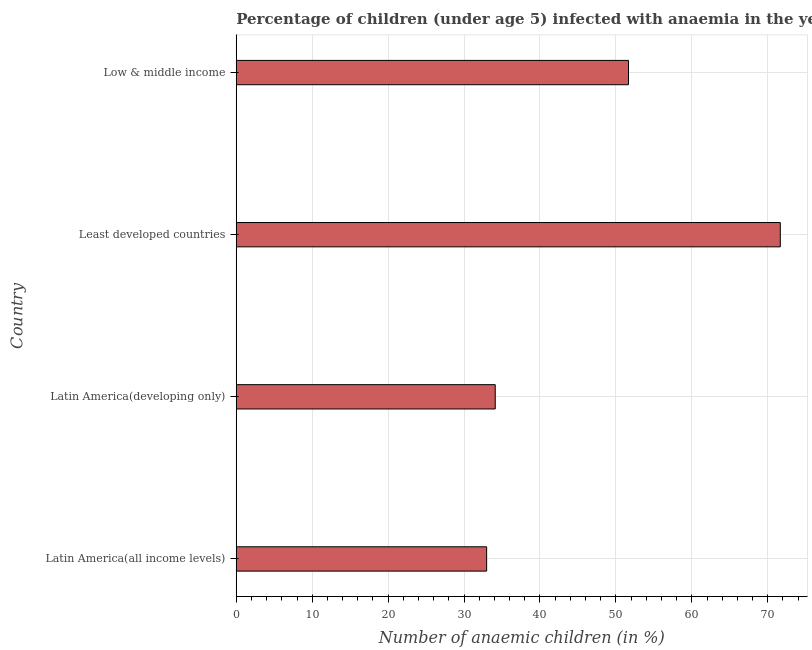Does the graph contain grids?
Provide a succinct answer. Yes. What is the title of the graph?
Give a very brief answer. Percentage of children (under age 5) infected with anaemia in the year 1996. What is the label or title of the X-axis?
Make the answer very short. Number of anaemic children (in %). What is the number of anaemic children in Latin America(all income levels)?
Provide a short and direct response. 32.98. Across all countries, what is the maximum number of anaemic children?
Your response must be concise. 71.65. Across all countries, what is the minimum number of anaemic children?
Provide a succinct answer. 32.98. In which country was the number of anaemic children maximum?
Offer a very short reply. Least developed countries. In which country was the number of anaemic children minimum?
Make the answer very short. Latin America(all income levels). What is the sum of the number of anaemic children?
Provide a short and direct response. 190.4. What is the difference between the number of anaemic children in Least developed countries and Low & middle income?
Offer a very short reply. 19.99. What is the average number of anaemic children per country?
Provide a short and direct response. 47.6. What is the median number of anaemic children?
Provide a short and direct response. 42.88. What is the ratio of the number of anaemic children in Latin America(all income levels) to that in Low & middle income?
Your answer should be very brief. 0.64. Is the difference between the number of anaemic children in Latin America(all income levels) and Least developed countries greater than the difference between any two countries?
Ensure brevity in your answer.  Yes. What is the difference between the highest and the second highest number of anaemic children?
Offer a very short reply. 19.99. Is the sum of the number of anaemic children in Latin America(all income levels) and Least developed countries greater than the maximum number of anaemic children across all countries?
Offer a terse response. Yes. What is the difference between the highest and the lowest number of anaemic children?
Offer a very short reply. 38.68. Are all the bars in the graph horizontal?
Make the answer very short. Yes. What is the difference between two consecutive major ticks on the X-axis?
Provide a short and direct response. 10. Are the values on the major ticks of X-axis written in scientific E-notation?
Your answer should be very brief. No. What is the Number of anaemic children (in %) of Latin America(all income levels)?
Offer a terse response. 32.98. What is the Number of anaemic children (in %) of Latin America(developing only)?
Your response must be concise. 34.11. What is the Number of anaemic children (in %) in Least developed countries?
Your answer should be very brief. 71.65. What is the Number of anaemic children (in %) of Low & middle income?
Your answer should be compact. 51.66. What is the difference between the Number of anaemic children (in %) in Latin America(all income levels) and Latin America(developing only)?
Keep it short and to the point. -1.13. What is the difference between the Number of anaemic children (in %) in Latin America(all income levels) and Least developed countries?
Offer a very short reply. -38.68. What is the difference between the Number of anaemic children (in %) in Latin America(all income levels) and Low & middle income?
Provide a short and direct response. -18.68. What is the difference between the Number of anaemic children (in %) in Latin America(developing only) and Least developed countries?
Your answer should be very brief. -37.54. What is the difference between the Number of anaemic children (in %) in Latin America(developing only) and Low & middle income?
Make the answer very short. -17.55. What is the difference between the Number of anaemic children (in %) in Least developed countries and Low & middle income?
Offer a terse response. 19.99. What is the ratio of the Number of anaemic children (in %) in Latin America(all income levels) to that in Latin America(developing only)?
Keep it short and to the point. 0.97. What is the ratio of the Number of anaemic children (in %) in Latin America(all income levels) to that in Least developed countries?
Ensure brevity in your answer.  0.46. What is the ratio of the Number of anaemic children (in %) in Latin America(all income levels) to that in Low & middle income?
Provide a short and direct response. 0.64. What is the ratio of the Number of anaemic children (in %) in Latin America(developing only) to that in Least developed countries?
Keep it short and to the point. 0.48. What is the ratio of the Number of anaemic children (in %) in Latin America(developing only) to that in Low & middle income?
Your answer should be very brief. 0.66. What is the ratio of the Number of anaemic children (in %) in Least developed countries to that in Low & middle income?
Your answer should be compact. 1.39. 